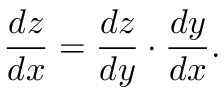<formula> <loc_0><loc_0><loc_500><loc_500>{ \frac { d z } { d x } } = { \frac { d z } { d y } } \cdot { \frac { d y } { d x } } .</formula> 